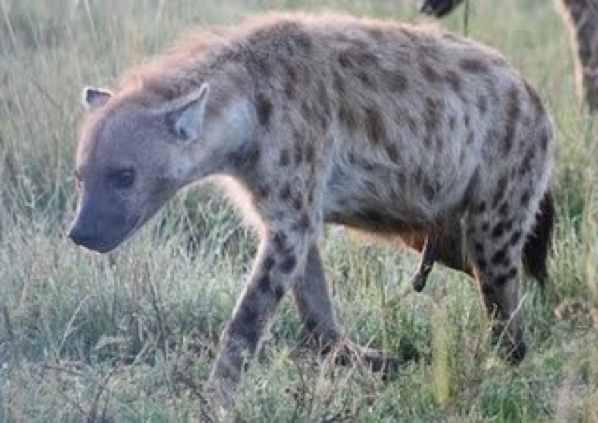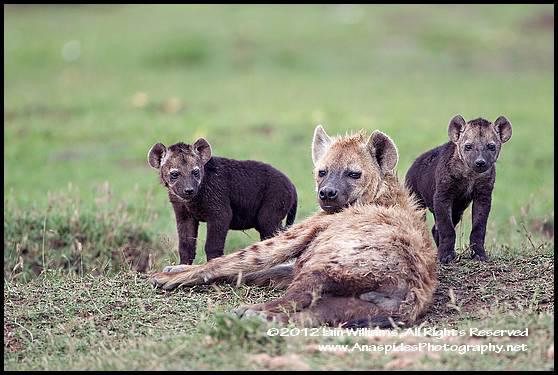The first image is the image on the left, the second image is the image on the right. Analyze the images presented: Is the assertion "The combined images include a scene with a hyena at the edge of water and include a hyena lying on its back." valid? Answer yes or no. No. The first image is the image on the left, the second image is the image on the right. Assess this claim about the two images: "The left image contains one hyena laying on its back.". Correct or not? Answer yes or no. No. 